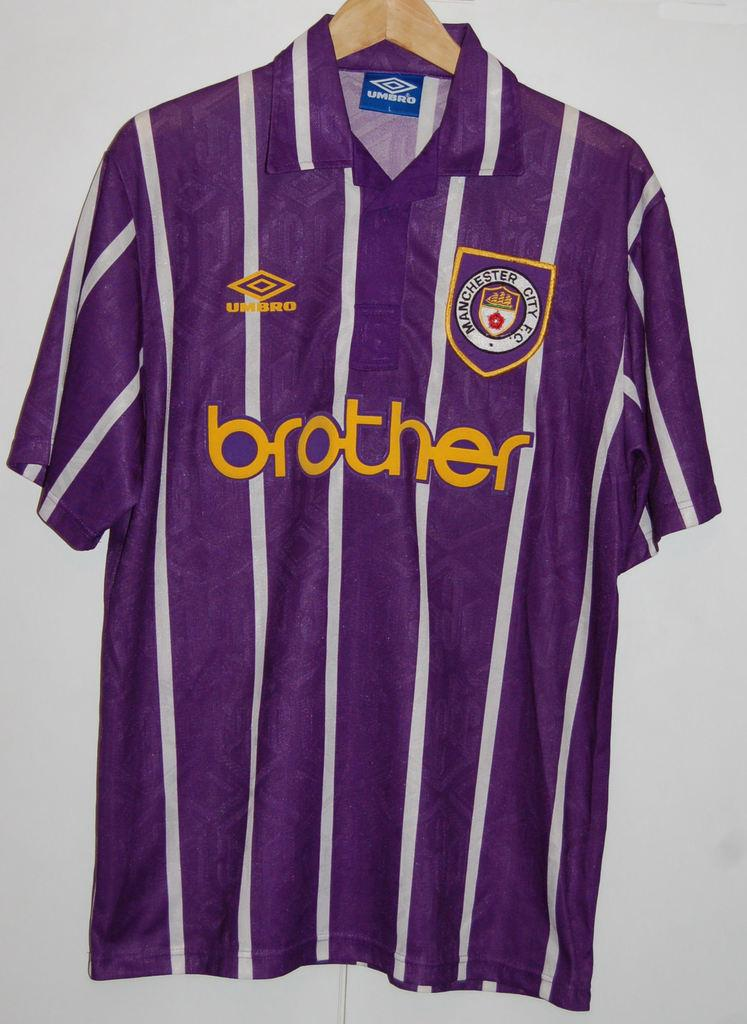<image>
Share a concise interpretation of the image provided. A purple jersey says "brother" on the front. 